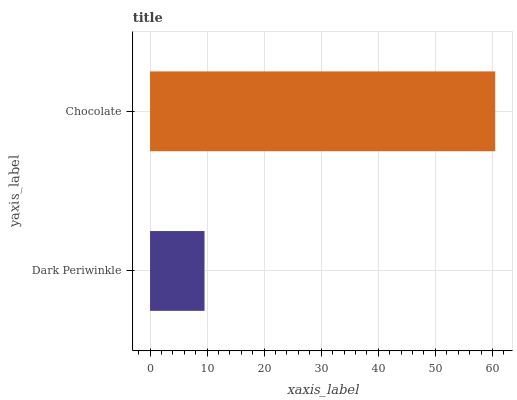Is Dark Periwinkle the minimum?
Answer yes or no. Yes. Is Chocolate the maximum?
Answer yes or no. Yes. Is Chocolate the minimum?
Answer yes or no. No. Is Chocolate greater than Dark Periwinkle?
Answer yes or no. Yes. Is Dark Periwinkle less than Chocolate?
Answer yes or no. Yes. Is Dark Periwinkle greater than Chocolate?
Answer yes or no. No. Is Chocolate less than Dark Periwinkle?
Answer yes or no. No. Is Chocolate the high median?
Answer yes or no. Yes. Is Dark Periwinkle the low median?
Answer yes or no. Yes. Is Dark Periwinkle the high median?
Answer yes or no. No. Is Chocolate the low median?
Answer yes or no. No. 